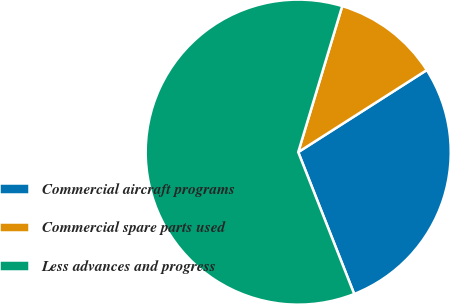Convert chart to OTSL. <chart><loc_0><loc_0><loc_500><loc_500><pie_chart><fcel>Commercial aircraft programs<fcel>Commercial spare parts used<fcel>Less advances and progress<nl><fcel>28.06%<fcel>11.3%<fcel>60.64%<nl></chart> 